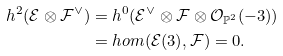Convert formula to latex. <formula><loc_0><loc_0><loc_500><loc_500>h ^ { 2 } ( \mathcal { E } \otimes \mathcal { F } ^ { \vee } ) & = h ^ { 0 } ( \mathcal { E } ^ { \vee } \otimes \mathcal { F } \otimes \mathcal { O } _ { \mathbb { P } ^ { 2 } } ( - 3 ) ) \\ & = h o m ( \mathcal { E } ( 3 ) , \mathcal { F } ) = 0 .</formula> 